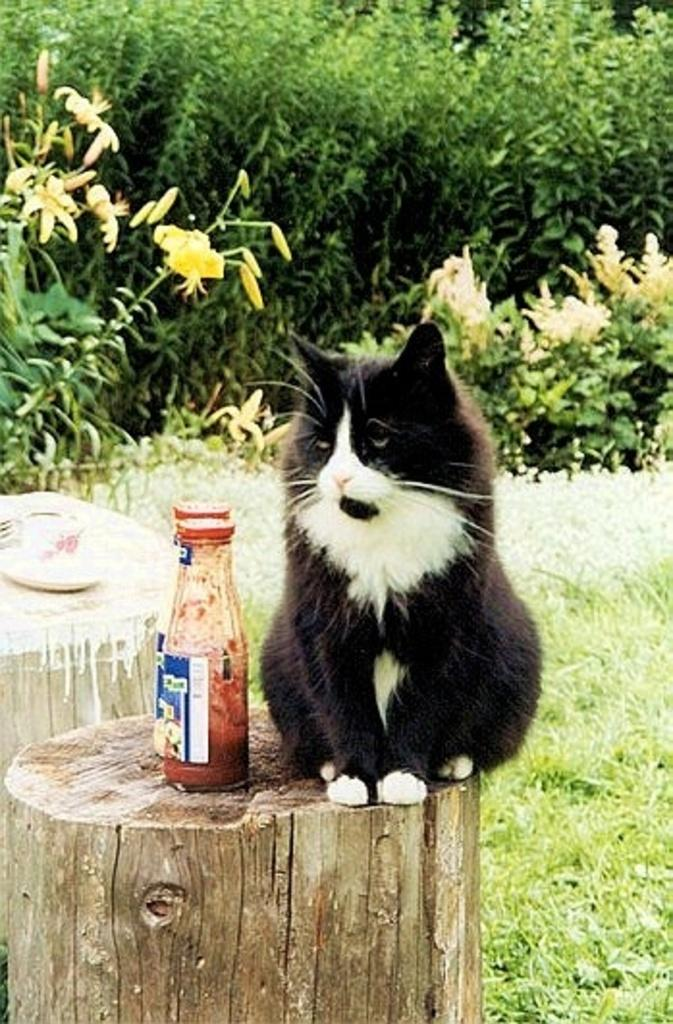What type of animal is in the image? There is a cat in the image. What is the cat doing in the image? The cat is sitting. How many bottles are next to the cat? There are 2 bottles next to the cat. What can be seen in the background of the image? There are plants and grass in the background of the image. What type of sock is the cat wearing in the image? There is no sock present in the image, and the cat is not wearing any clothing. 